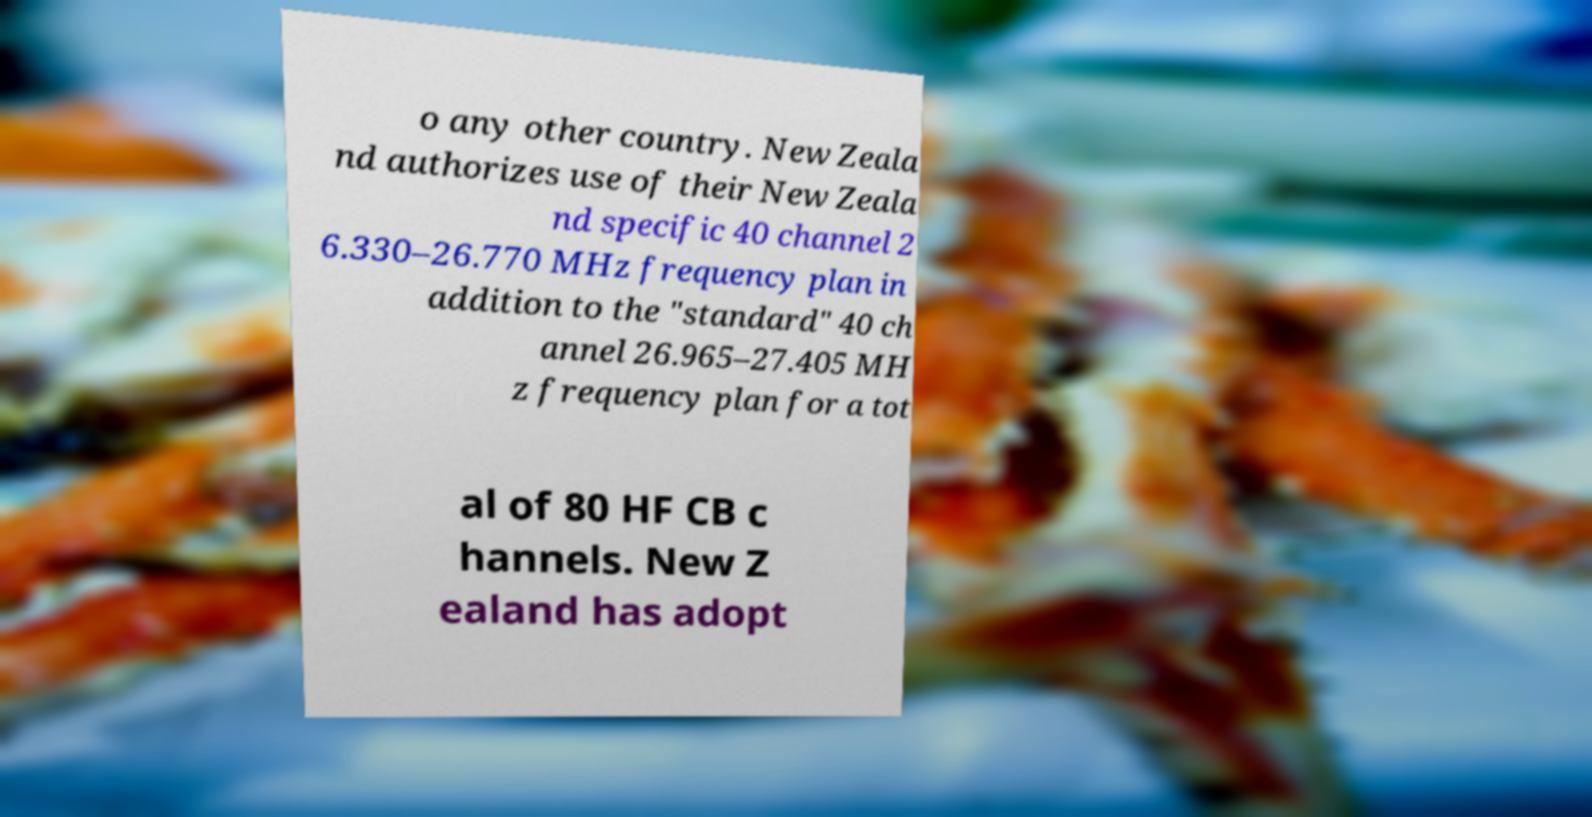Please read and relay the text visible in this image. What does it say? o any other country. New Zeala nd authorizes use of their New Zeala nd specific 40 channel 2 6.330–26.770 MHz frequency plan in addition to the "standard" 40 ch annel 26.965–27.405 MH z frequency plan for a tot al of 80 HF CB c hannels. New Z ealand has adopt 